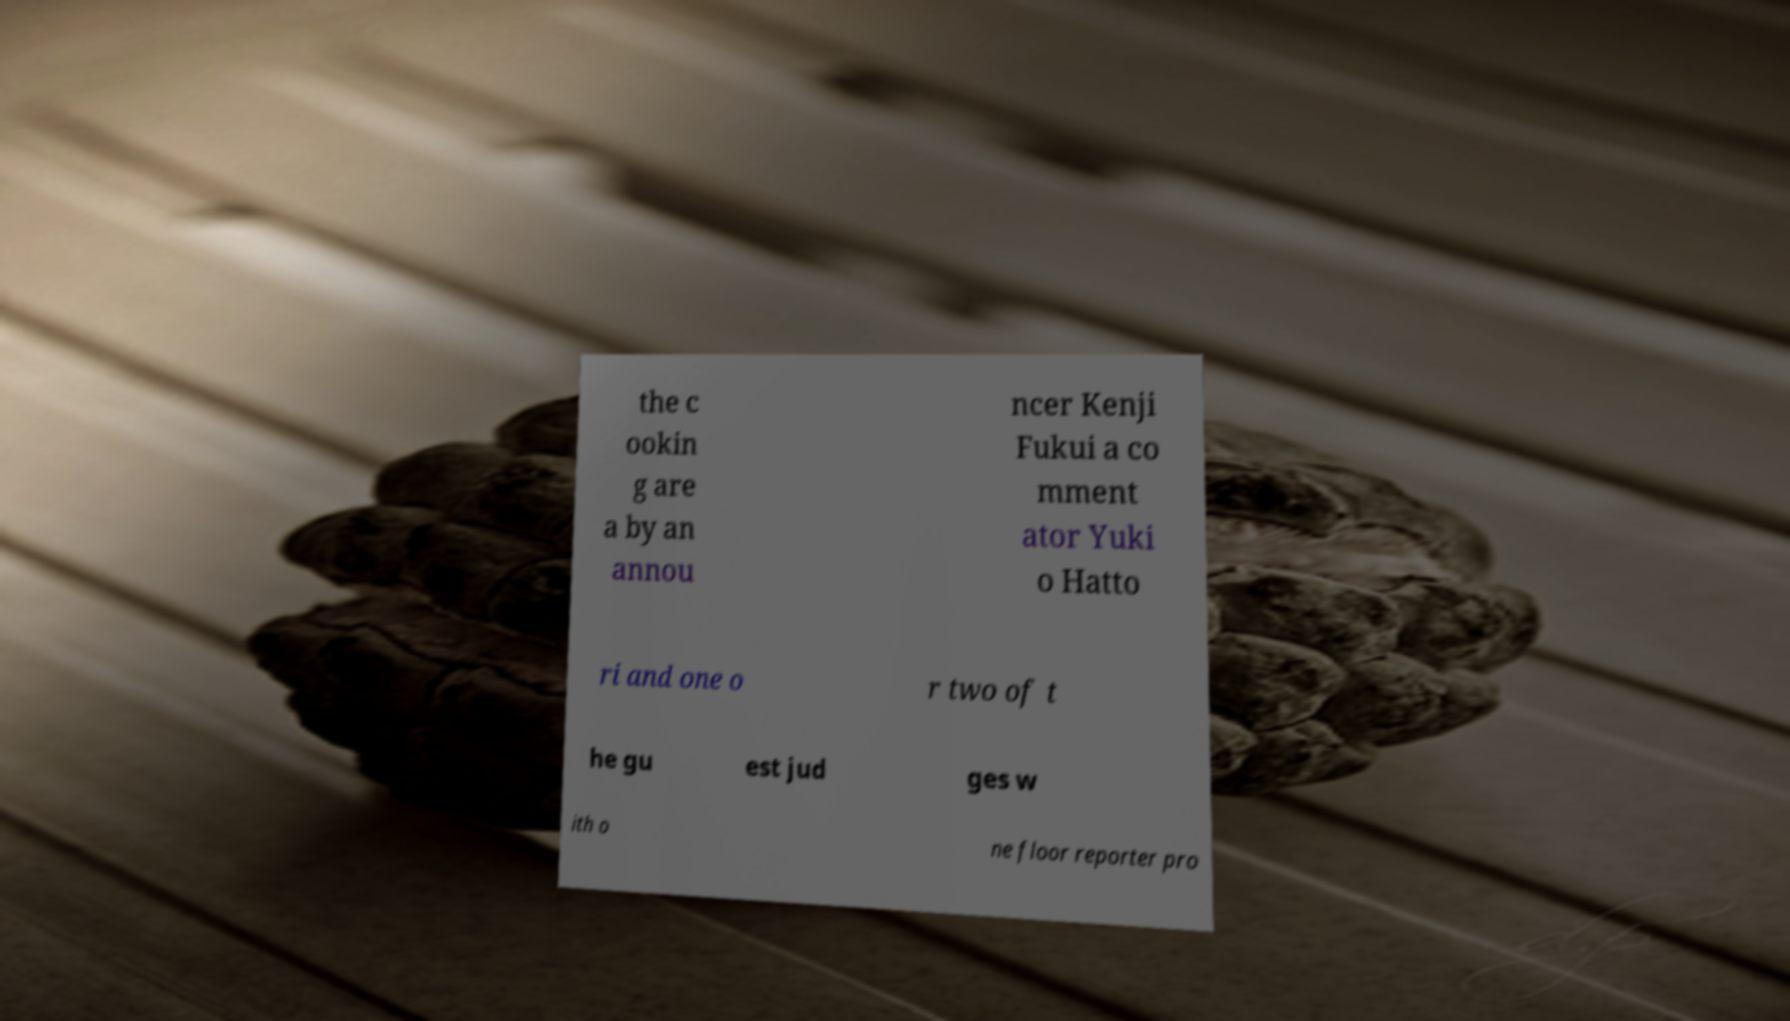Please identify and transcribe the text found in this image. the c ookin g are a by an annou ncer Kenji Fukui a co mment ator Yuki o Hatto ri and one o r two of t he gu est jud ges w ith o ne floor reporter pro 